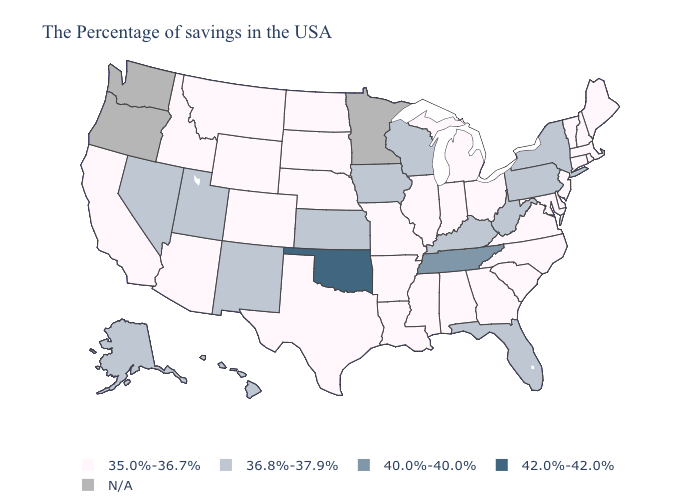What is the value of Arkansas?
Give a very brief answer. 35.0%-36.7%. Name the states that have a value in the range 40.0%-40.0%?
Concise answer only. Tennessee. What is the value of Florida?
Be succinct. 36.8%-37.9%. What is the highest value in the USA?
Quick response, please. 42.0%-42.0%. Which states have the highest value in the USA?
Quick response, please. Oklahoma. Which states have the highest value in the USA?
Keep it brief. Oklahoma. Among the states that border Louisiana , which have the highest value?
Write a very short answer. Mississippi, Arkansas, Texas. Does Oklahoma have the highest value in the USA?
Be succinct. Yes. Name the states that have a value in the range N/A?
Write a very short answer. Minnesota, Washington, Oregon. Does the first symbol in the legend represent the smallest category?
Concise answer only. Yes. Does the map have missing data?
Keep it brief. Yes. What is the highest value in the USA?
Write a very short answer. 42.0%-42.0%. What is the value of North Carolina?
Concise answer only. 35.0%-36.7%. What is the lowest value in the USA?
Write a very short answer. 35.0%-36.7%. What is the value of California?
Give a very brief answer. 35.0%-36.7%. 